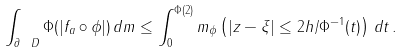<formula> <loc_0><loc_0><loc_500><loc_500>\int _ { \partial \ D } \Phi ( | f _ { a } \circ \phi | ) \, d m \leq \int _ { 0 } ^ { \Phi ( 2 ) } m _ { \phi } \left ( | z - \xi | \leq 2 h / \Phi ^ { - 1 } ( t ) \right ) \, d t \, .</formula> 